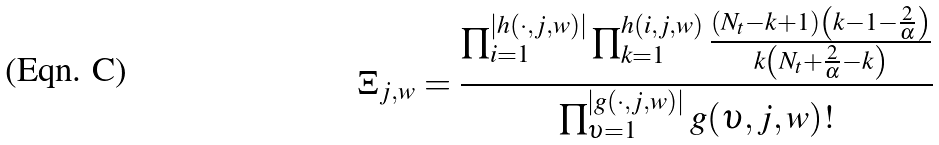Convert formula to latex. <formula><loc_0><loc_0><loc_500><loc_500>\Xi _ { j , w } & = \frac { \prod _ { i = 1 } ^ { | h ( \cdot , j , w ) | } \prod _ { k = 1 } ^ { h ( i , j , w ) } \frac { \left ( N _ { t } - k + 1 \right ) \left ( k - 1 - \frac { 2 } { \alpha } \right ) } { k \left ( N _ { t } + \frac { 2 } { \alpha } - k \right ) } } { \prod _ { \upsilon = 1 } ^ { | g ( \cdot , j , w ) | } g ( \upsilon , j , w ) ! }</formula> 